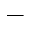Convert formula to latex. <formula><loc_0><loc_0><loc_500><loc_500>-</formula> 